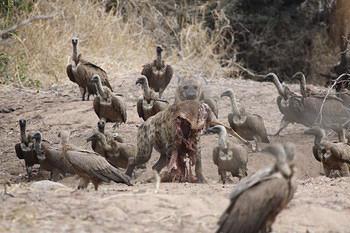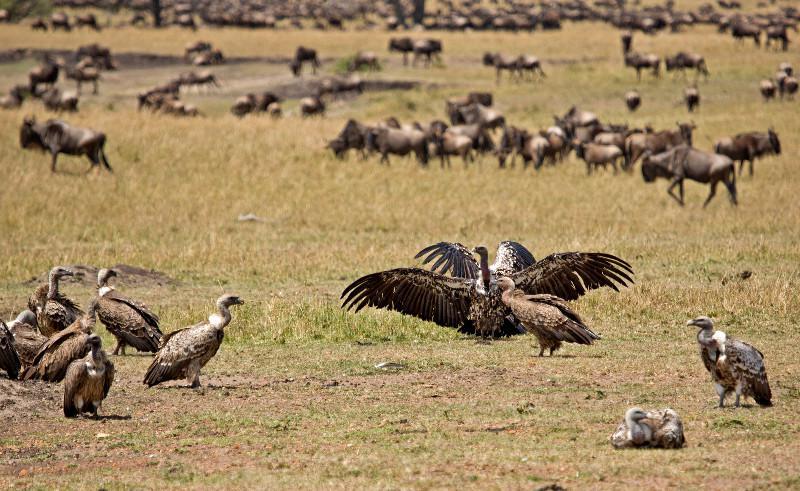The first image is the image on the left, the second image is the image on the right. Examine the images to the left and right. Is the description "There is at least one bird with extended wings in the image on the right." accurate? Answer yes or no. Yes. 